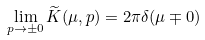<formula> <loc_0><loc_0><loc_500><loc_500>\lim _ { p \rightarrow \pm 0 } \widetilde { K } ( \mu , p ) = 2 \pi \delta ( \mu \mp 0 )</formula> 